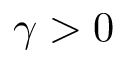Convert formula to latex. <formula><loc_0><loc_0><loc_500><loc_500>\gamma > 0</formula> 